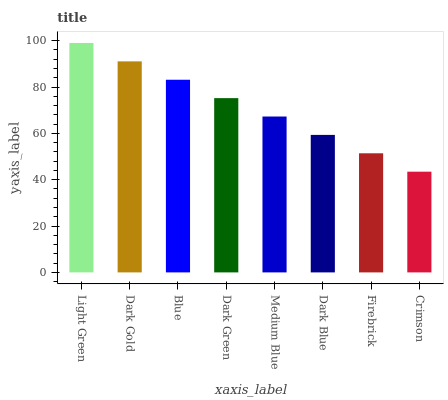Is Crimson the minimum?
Answer yes or no. Yes. Is Light Green the maximum?
Answer yes or no. Yes. Is Dark Gold the minimum?
Answer yes or no. No. Is Dark Gold the maximum?
Answer yes or no. No. Is Light Green greater than Dark Gold?
Answer yes or no. Yes. Is Dark Gold less than Light Green?
Answer yes or no. Yes. Is Dark Gold greater than Light Green?
Answer yes or no. No. Is Light Green less than Dark Gold?
Answer yes or no. No. Is Dark Green the high median?
Answer yes or no. Yes. Is Medium Blue the low median?
Answer yes or no. Yes. Is Crimson the high median?
Answer yes or no. No. Is Firebrick the low median?
Answer yes or no. No. 